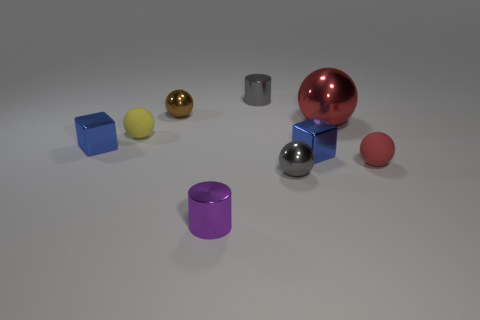There is another small thing that is the same shape as the tiny purple object; what is its color?
Offer a terse response. Gray. There is a small red thing; does it have the same shape as the red metallic object right of the small yellow object?
Provide a short and direct response. Yes. What number of objects are tiny metal spheres that are to the right of the brown ball or cylinders behind the brown ball?
Make the answer very short. 2. Is the number of tiny red things behind the red rubber sphere less than the number of purple shiny cylinders?
Provide a short and direct response. Yes. Do the big object and the red sphere in front of the tiny yellow matte ball have the same material?
Offer a very short reply. No. What is the material of the large thing?
Make the answer very short. Metal. The tiny brown sphere behind the rubber sphere that is to the left of the cylinder in front of the red rubber sphere is made of what material?
Provide a succinct answer. Metal. There is a big metallic thing; is its color the same as the small rubber sphere that is on the right side of the tiny gray metallic ball?
Give a very brief answer. Yes. What is the color of the small shiny block left of the sphere that is in front of the tiny red rubber thing?
Offer a terse response. Blue. How many red balls are there?
Make the answer very short. 2. 